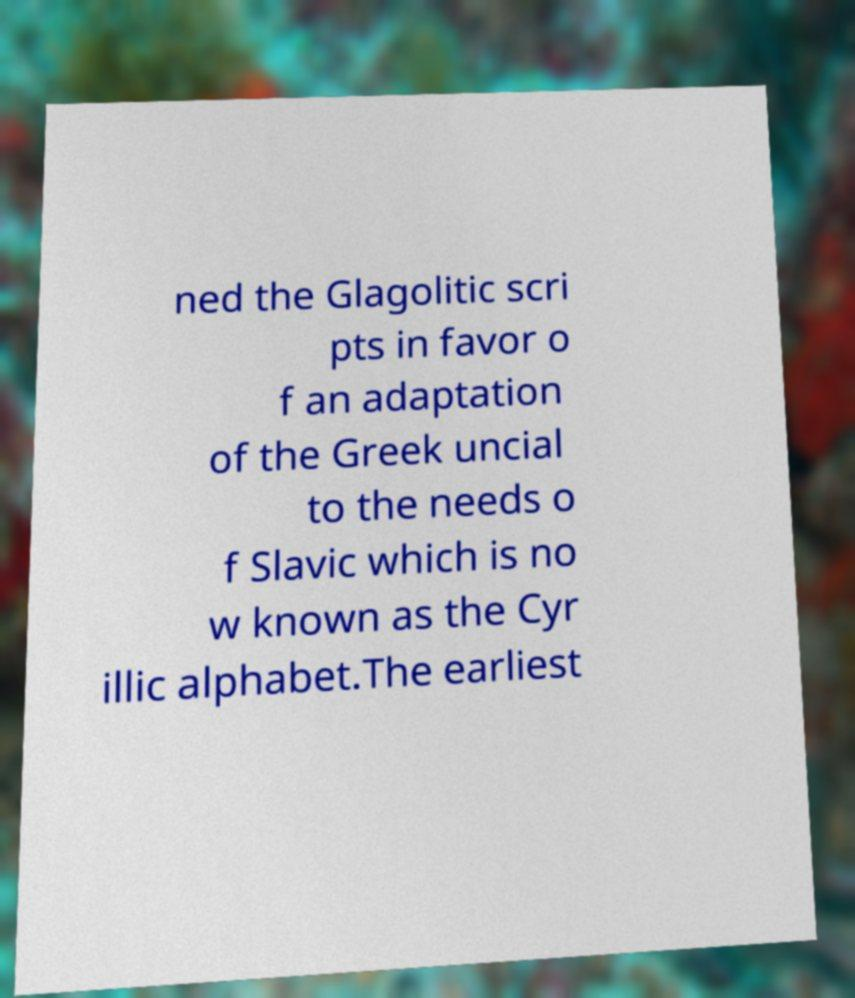What messages or text are displayed in this image? I need them in a readable, typed format. ned the Glagolitic scri pts in favor o f an adaptation of the Greek uncial to the needs o f Slavic which is no w known as the Cyr illic alphabet.The earliest 